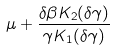<formula> <loc_0><loc_0><loc_500><loc_500>\mu + \frac { \delta \beta K _ { 2 } ( \delta \gamma ) } { \gamma K _ { 1 } ( \delta \gamma ) }</formula> 